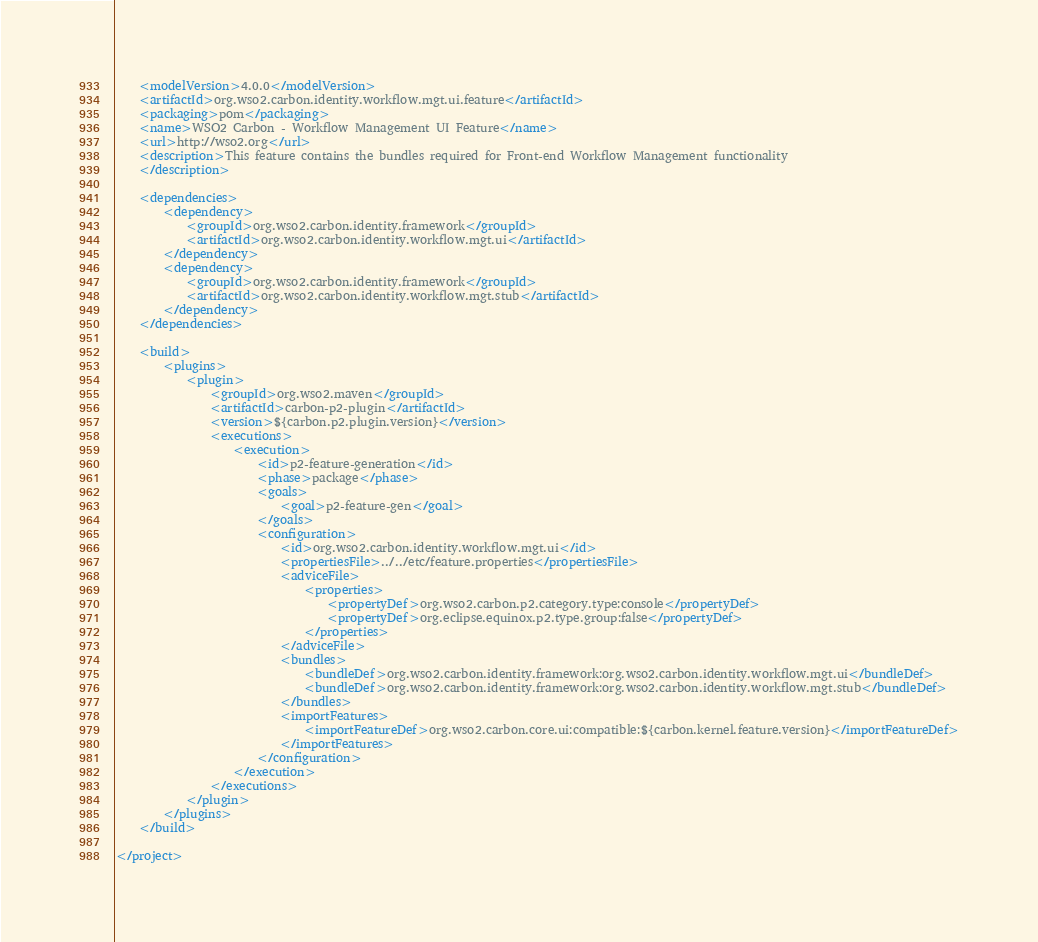<code> <loc_0><loc_0><loc_500><loc_500><_XML_>    <modelVersion>4.0.0</modelVersion>
    <artifactId>org.wso2.carbon.identity.workflow.mgt.ui.feature</artifactId>
    <packaging>pom</packaging>
    <name>WSO2 Carbon - Workflow Management UI Feature</name>
    <url>http://wso2.org</url>
    <description>This feature contains the bundles required for Front-end Workflow Management functionality
    </description>

    <dependencies>
        <dependency>
            <groupId>org.wso2.carbon.identity.framework</groupId>
            <artifactId>org.wso2.carbon.identity.workflow.mgt.ui</artifactId>
        </dependency>
        <dependency>
            <groupId>org.wso2.carbon.identity.framework</groupId>
            <artifactId>org.wso2.carbon.identity.workflow.mgt.stub</artifactId>
        </dependency>
	</dependencies>

    <build>
        <plugins>
            <plugin>
                <groupId>org.wso2.maven</groupId>
                <artifactId>carbon-p2-plugin</artifactId>
                <version>${carbon.p2.plugin.version}</version>
                <executions>
                    <execution>
                        <id>p2-feature-generation</id>
                        <phase>package</phase>
                        <goals>
                            <goal>p2-feature-gen</goal>
                        </goals>
                        <configuration>
                            <id>org.wso2.carbon.identity.workflow.mgt.ui</id>
                            <propertiesFile>../../etc/feature.properties</propertiesFile>
                            <adviceFile>
                                <properties>
                                    <propertyDef>org.wso2.carbon.p2.category.type:console</propertyDef>
                                    <propertyDef>org.eclipse.equinox.p2.type.group:false</propertyDef>
                                </properties>
                            </adviceFile>
                            <bundles>
                                <bundleDef>org.wso2.carbon.identity.framework:org.wso2.carbon.identity.workflow.mgt.ui</bundleDef>
                                <bundleDef>org.wso2.carbon.identity.framework:org.wso2.carbon.identity.workflow.mgt.stub</bundleDef>
                            </bundles>
                            <importFeatures>
                                <importFeatureDef>org.wso2.carbon.core.ui:compatible:${carbon.kernel.feature.version}</importFeatureDef>
                            </importFeatures>
                        </configuration>
                    </execution>
                </executions>
            </plugin>
        </plugins>
    </build>

</project>
</code> 